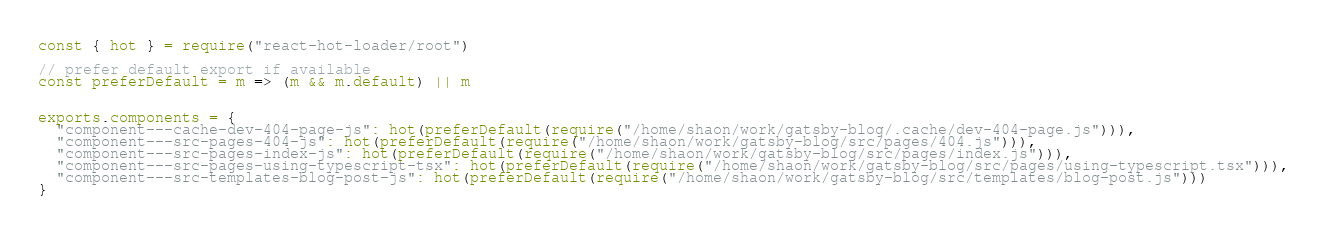Convert code to text. <code><loc_0><loc_0><loc_500><loc_500><_JavaScript_>const { hot } = require("react-hot-loader/root")

// prefer default export if available
const preferDefault = m => (m && m.default) || m


exports.components = {
  "component---cache-dev-404-page-js": hot(preferDefault(require("/home/shaon/work/gatsby-blog/.cache/dev-404-page.js"))),
  "component---src-pages-404-js": hot(preferDefault(require("/home/shaon/work/gatsby-blog/src/pages/404.js"))),
  "component---src-pages-index-js": hot(preferDefault(require("/home/shaon/work/gatsby-blog/src/pages/index.js"))),
  "component---src-pages-using-typescript-tsx": hot(preferDefault(require("/home/shaon/work/gatsby-blog/src/pages/using-typescript.tsx"))),
  "component---src-templates-blog-post-js": hot(preferDefault(require("/home/shaon/work/gatsby-blog/src/templates/blog-post.js")))
}

</code> 